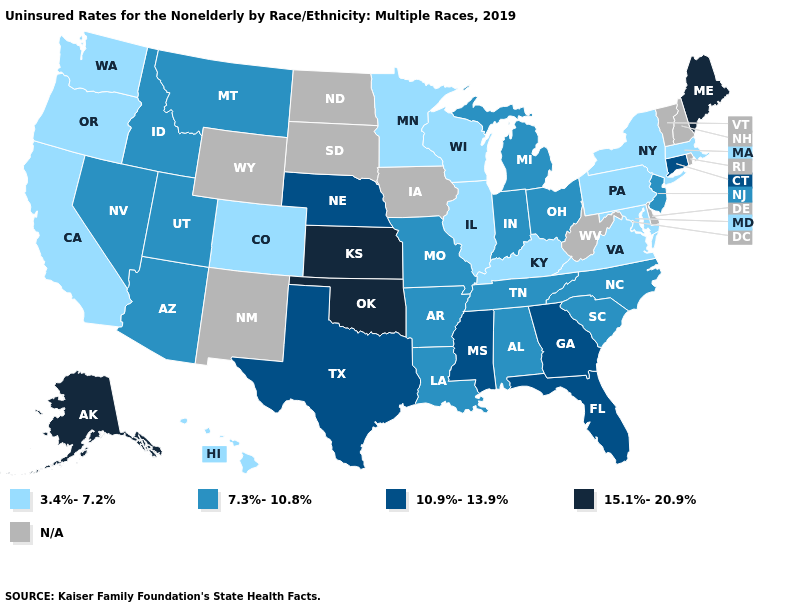Which states have the lowest value in the USA?
Quick response, please. California, Colorado, Hawaii, Illinois, Kentucky, Maryland, Massachusetts, Minnesota, New York, Oregon, Pennsylvania, Virginia, Washington, Wisconsin. Name the states that have a value in the range 7.3%-10.8%?
Give a very brief answer. Alabama, Arizona, Arkansas, Idaho, Indiana, Louisiana, Michigan, Missouri, Montana, Nevada, New Jersey, North Carolina, Ohio, South Carolina, Tennessee, Utah. What is the highest value in the Northeast ?
Give a very brief answer. 15.1%-20.9%. What is the value of California?
Short answer required. 3.4%-7.2%. Does New York have the highest value in the Northeast?
Give a very brief answer. No. Among the states that border New Mexico , does Texas have the lowest value?
Write a very short answer. No. What is the value of Alabama?
Write a very short answer. 7.3%-10.8%. Which states hav the highest value in the West?
Quick response, please. Alaska. What is the value of Minnesota?
Keep it brief. 3.4%-7.2%. What is the highest value in the USA?
Write a very short answer. 15.1%-20.9%. What is the highest value in the USA?
Give a very brief answer. 15.1%-20.9%. Does Massachusetts have the lowest value in the USA?
Give a very brief answer. Yes. 